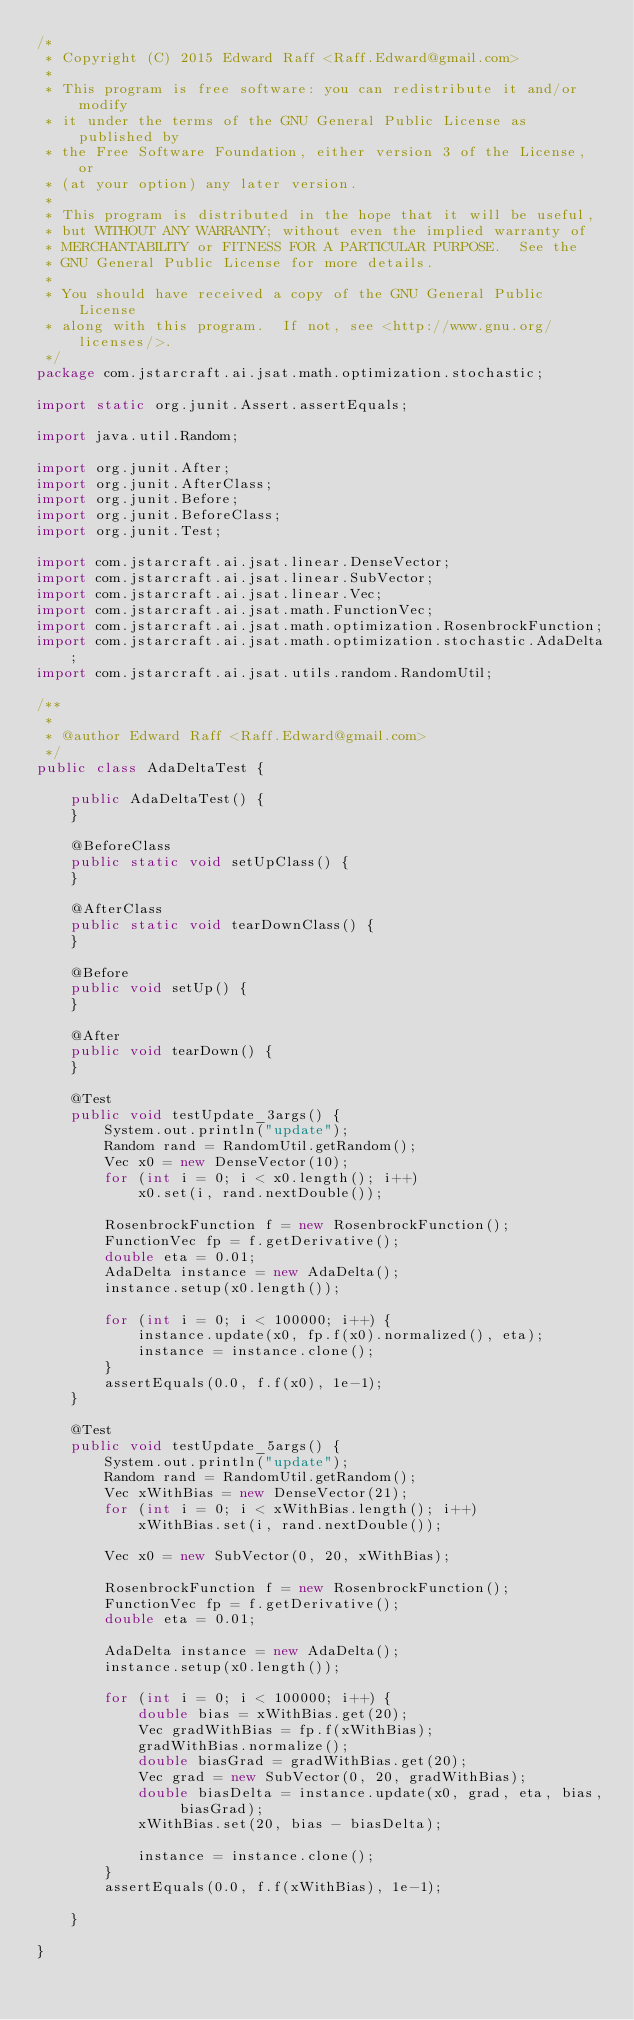Convert code to text. <code><loc_0><loc_0><loc_500><loc_500><_Java_>/*
 * Copyright (C) 2015 Edward Raff <Raff.Edward@gmail.com>
 *
 * This program is free software: you can redistribute it and/or modify
 * it under the terms of the GNU General Public License as published by
 * the Free Software Foundation, either version 3 of the License, or
 * (at your option) any later version.
 *
 * This program is distributed in the hope that it will be useful,
 * but WITHOUT ANY WARRANTY; without even the implied warranty of
 * MERCHANTABILITY or FITNESS FOR A PARTICULAR PURPOSE.  See the
 * GNU General Public License for more details.
 *
 * You should have received a copy of the GNU General Public License
 * along with this program.  If not, see <http://www.gnu.org/licenses/>.
 */
package com.jstarcraft.ai.jsat.math.optimization.stochastic;

import static org.junit.Assert.assertEquals;

import java.util.Random;

import org.junit.After;
import org.junit.AfterClass;
import org.junit.Before;
import org.junit.BeforeClass;
import org.junit.Test;

import com.jstarcraft.ai.jsat.linear.DenseVector;
import com.jstarcraft.ai.jsat.linear.SubVector;
import com.jstarcraft.ai.jsat.linear.Vec;
import com.jstarcraft.ai.jsat.math.FunctionVec;
import com.jstarcraft.ai.jsat.math.optimization.RosenbrockFunction;
import com.jstarcraft.ai.jsat.math.optimization.stochastic.AdaDelta;
import com.jstarcraft.ai.jsat.utils.random.RandomUtil;

/**
 *
 * @author Edward Raff <Raff.Edward@gmail.com>
 */
public class AdaDeltaTest {

    public AdaDeltaTest() {
    }

    @BeforeClass
    public static void setUpClass() {
    }

    @AfterClass
    public static void tearDownClass() {
    }

    @Before
    public void setUp() {
    }

    @After
    public void tearDown() {
    }

    @Test
    public void testUpdate_3args() {
        System.out.println("update");
        Random rand = RandomUtil.getRandom();
        Vec x0 = new DenseVector(10);
        for (int i = 0; i < x0.length(); i++)
            x0.set(i, rand.nextDouble());

        RosenbrockFunction f = new RosenbrockFunction();
        FunctionVec fp = f.getDerivative();
        double eta = 0.01;
        AdaDelta instance = new AdaDelta();
        instance.setup(x0.length());

        for (int i = 0; i < 100000; i++) {
            instance.update(x0, fp.f(x0).normalized(), eta);
            instance = instance.clone();
        }
        assertEquals(0.0, f.f(x0), 1e-1);
    }

    @Test
    public void testUpdate_5args() {
        System.out.println("update");
        Random rand = RandomUtil.getRandom();
        Vec xWithBias = new DenseVector(21);
        for (int i = 0; i < xWithBias.length(); i++)
            xWithBias.set(i, rand.nextDouble());

        Vec x0 = new SubVector(0, 20, xWithBias);

        RosenbrockFunction f = new RosenbrockFunction();
        FunctionVec fp = f.getDerivative();
        double eta = 0.01;

        AdaDelta instance = new AdaDelta();
        instance.setup(x0.length());

        for (int i = 0; i < 100000; i++) {
            double bias = xWithBias.get(20);
            Vec gradWithBias = fp.f(xWithBias);
            gradWithBias.normalize();
            double biasGrad = gradWithBias.get(20);
            Vec grad = new SubVector(0, 20, gradWithBias);
            double biasDelta = instance.update(x0, grad, eta, bias, biasGrad);
            xWithBias.set(20, bias - biasDelta);

            instance = instance.clone();
        }
        assertEquals(0.0, f.f(xWithBias), 1e-1);

    }

}
</code> 